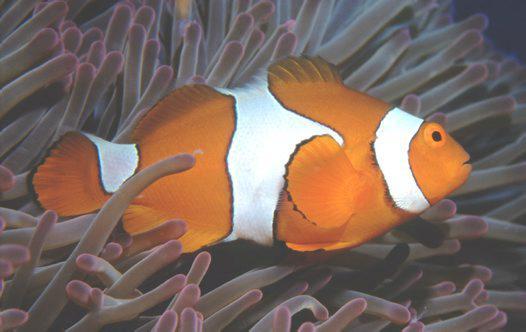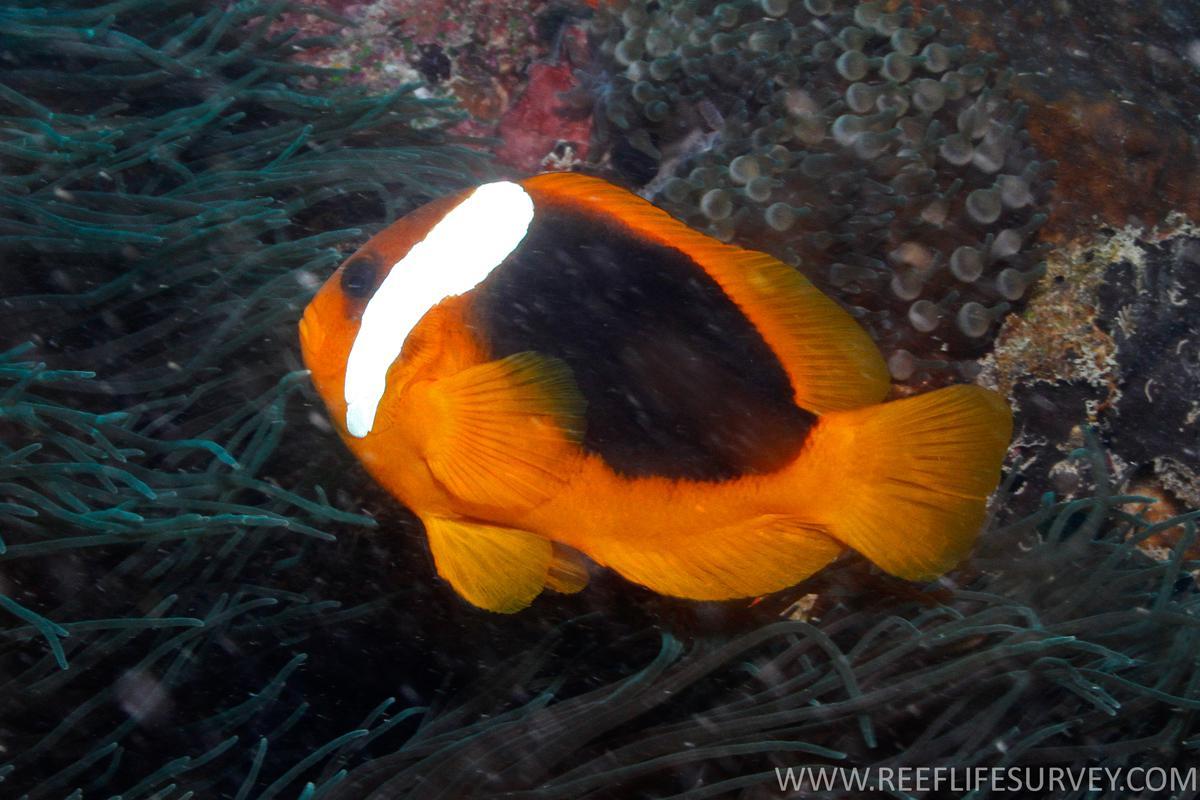The first image is the image on the left, the second image is the image on the right. Given the left and right images, does the statement "There is a single clownfish swimming by the reef." hold true? Answer yes or no. Yes. 